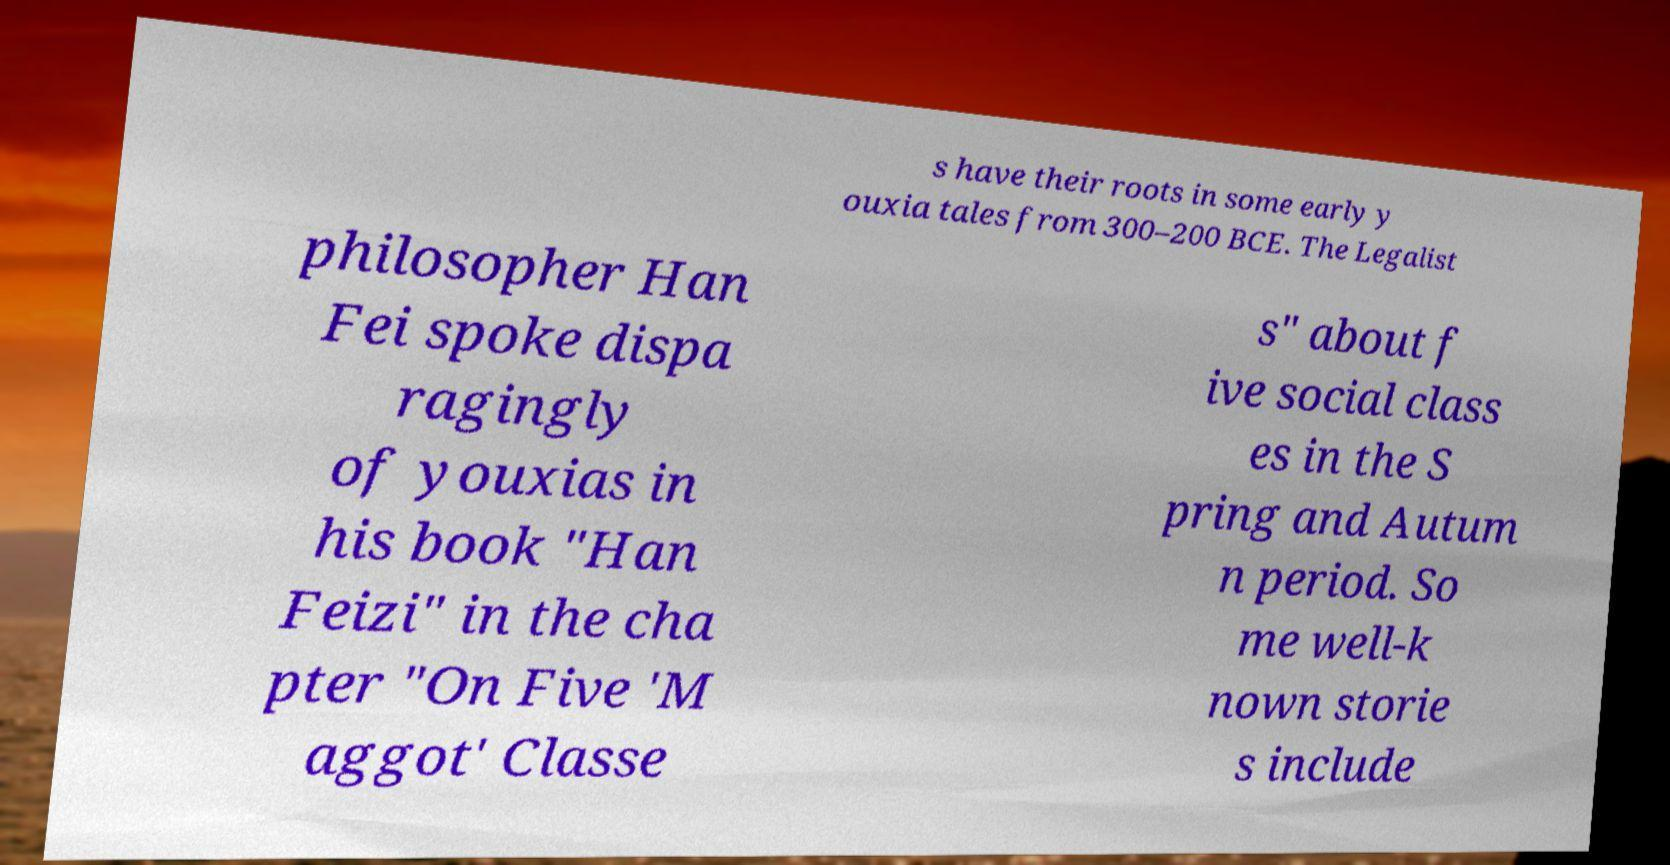Could you extract and type out the text from this image? s have their roots in some early y ouxia tales from 300–200 BCE. The Legalist philosopher Han Fei spoke dispa ragingly of youxias in his book "Han Feizi" in the cha pter "On Five 'M aggot' Classe s" about f ive social class es in the S pring and Autum n period. So me well-k nown storie s include 